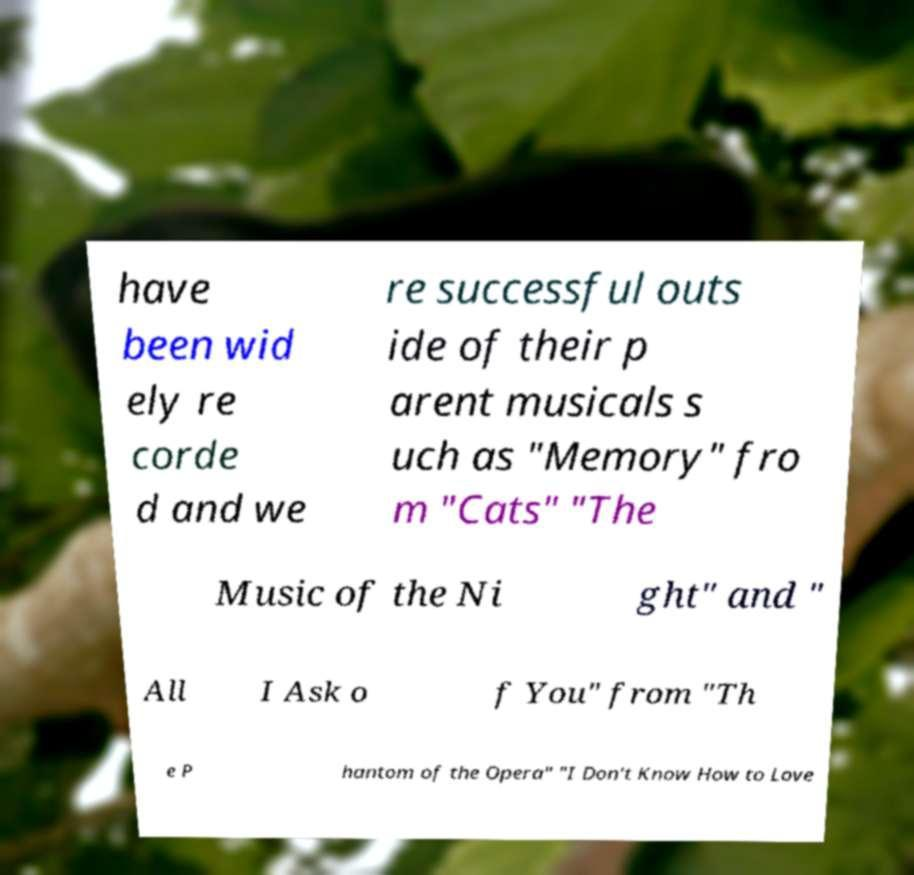Please identify and transcribe the text found in this image. have been wid ely re corde d and we re successful outs ide of their p arent musicals s uch as "Memory" fro m "Cats" "The Music of the Ni ght" and " All I Ask o f You" from "Th e P hantom of the Opera" "I Don't Know How to Love 